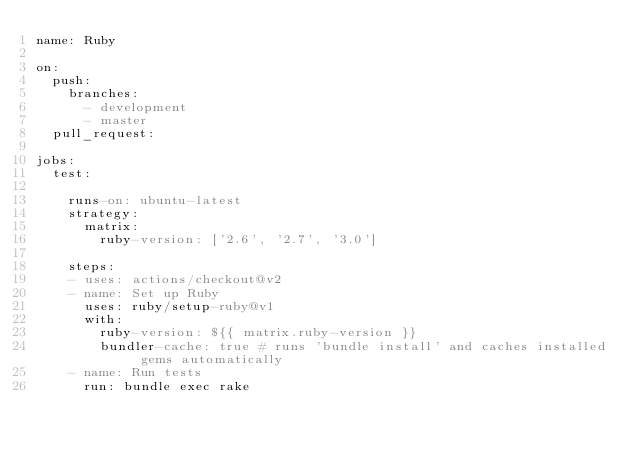Convert code to text. <code><loc_0><loc_0><loc_500><loc_500><_YAML_>name: Ruby

on:
  push:
    branches:
      - development
      - master
  pull_request:
  
jobs:
  test:

    runs-on: ubuntu-latest
    strategy:
      matrix:
        ruby-version: ['2.6', '2.7', '3.0']

    steps:
    - uses: actions/checkout@v2
    - name: Set up Ruby
      uses: ruby/setup-ruby@v1
      with:
        ruby-version: ${{ matrix.ruby-version }}
        bundler-cache: true # runs 'bundle install' and caches installed gems automatically
    - name: Run tests
      run: bundle exec rake
</code> 